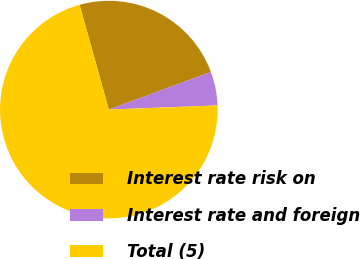Convert chart. <chart><loc_0><loc_0><loc_500><loc_500><pie_chart><fcel>Interest rate risk on<fcel>Interest rate and foreign<fcel>Total (5)<nl><fcel>23.71%<fcel>5.01%<fcel>71.27%<nl></chart> 